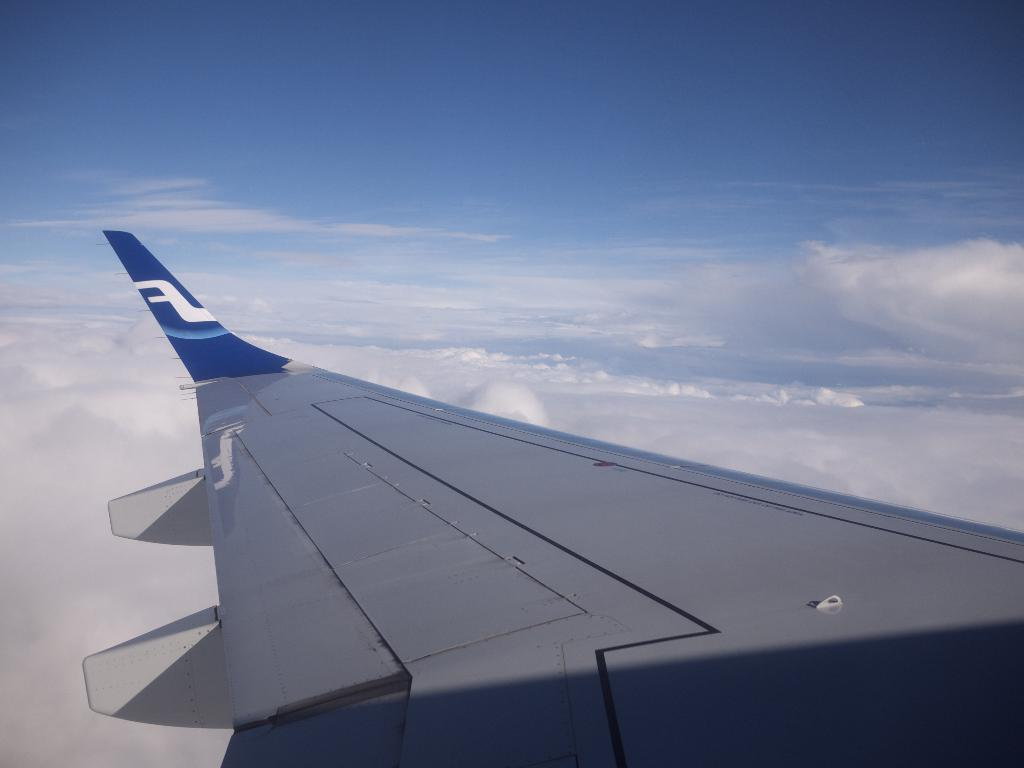What is the main subject of the image? The main subject of the image is an airplane wing. What colors are used for the airplane wing? The airplane wing is in blue and white colors. What can be seen in the background of the image? There are clouds and a clear sky in the background of the image. Can you tell me how many passengers are sitting on the whip in the image? There is no whip or passengers present in the image; it features an airplane wing. What type of tub is visible in the image? There is no tub present in the image. 